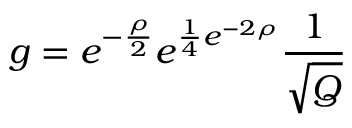<formula> <loc_0><loc_0><loc_500><loc_500>g = e ^ { - \frac { \rho } { 2 } } e ^ { \frac { 1 } { 4 } e ^ { - 2 \rho } } \frac { 1 } { \sqrt { Q } }</formula> 